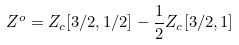<formula> <loc_0><loc_0><loc_500><loc_500>Z ^ { o } = Z _ { c } [ 3 / 2 , 1 / 2 ] - \frac { 1 } { 2 } Z _ { c } [ 3 / 2 , 1 ]</formula> 